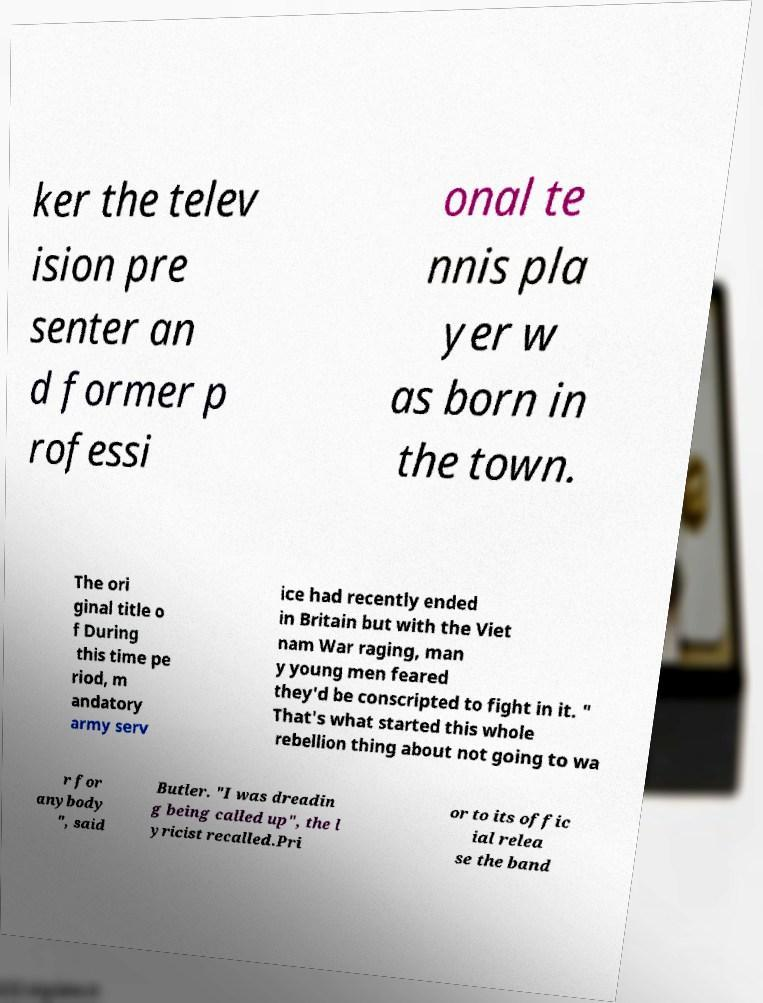There's text embedded in this image that I need extracted. Can you transcribe it verbatim? ker the telev ision pre senter an d former p rofessi onal te nnis pla yer w as born in the town. The ori ginal title o f During this time pe riod, m andatory army serv ice had recently ended in Britain but with the Viet nam War raging, man y young men feared they'd be conscripted to fight in it. " That's what started this whole rebellion thing about not going to wa r for anybody ", said Butler. "I was dreadin g being called up", the l yricist recalled.Pri or to its offic ial relea se the band 